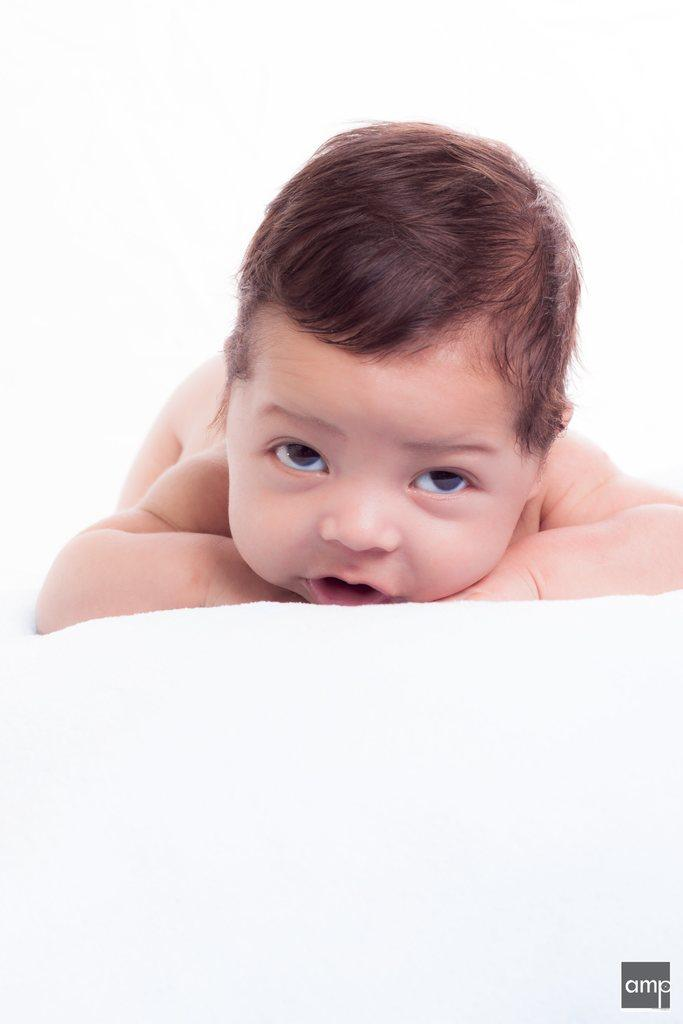What is the main subject of the image? The main subject of the image is a kid. What is the kid doing in the image? The kid is lying on something. What type of agreement is being signed by the kid in the image? There is no indication in the image that the kid is signing any agreement, as the facts only mention that the kid is lying on something. 